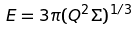<formula> <loc_0><loc_0><loc_500><loc_500>E = 3 \pi ( Q ^ { 2 } \Sigma ) ^ { 1 / 3 }</formula> 